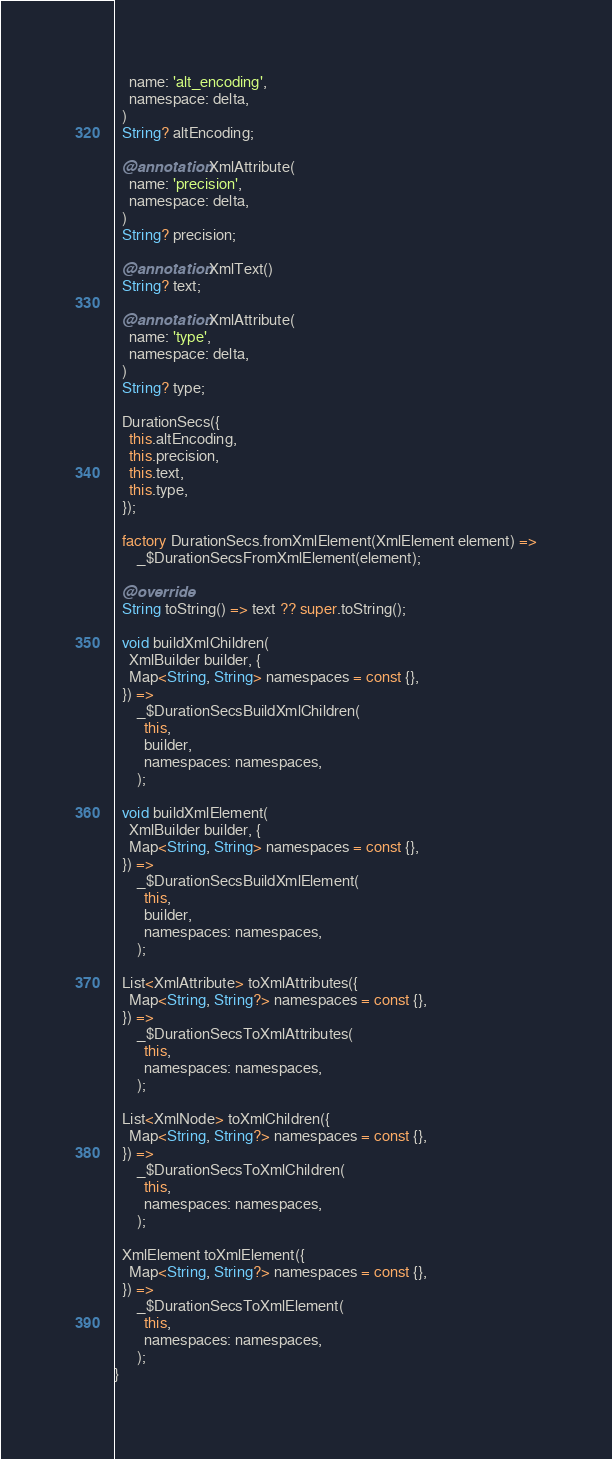Convert code to text. <code><loc_0><loc_0><loc_500><loc_500><_Dart_>    name: 'alt_encoding',
    namespace: delta,
  )
  String? altEncoding;

  @annotation.XmlAttribute(
    name: 'precision',
    namespace: delta,
  )
  String? precision;

  @annotation.XmlText()
  String? text;

  @annotation.XmlAttribute(
    name: 'type',
    namespace: delta,
  )
  String? type;

  DurationSecs({
    this.altEncoding,
    this.precision,
    this.text,
    this.type,
  });

  factory DurationSecs.fromXmlElement(XmlElement element) =>
      _$DurationSecsFromXmlElement(element);

  @override
  String toString() => text ?? super.toString();

  void buildXmlChildren(
    XmlBuilder builder, {
    Map<String, String> namespaces = const {},
  }) =>
      _$DurationSecsBuildXmlChildren(
        this,
        builder,
        namespaces: namespaces,
      );

  void buildXmlElement(
    XmlBuilder builder, {
    Map<String, String> namespaces = const {},
  }) =>
      _$DurationSecsBuildXmlElement(
        this,
        builder,
        namespaces: namespaces,
      );

  List<XmlAttribute> toXmlAttributes({
    Map<String, String?> namespaces = const {},
  }) =>
      _$DurationSecsToXmlAttributes(
        this,
        namespaces: namespaces,
      );

  List<XmlNode> toXmlChildren({
    Map<String, String?> namespaces = const {},
  }) =>
      _$DurationSecsToXmlChildren(
        this,
        namespaces: namespaces,
      );

  XmlElement toXmlElement({
    Map<String, String?> namespaces = const {},
  }) =>
      _$DurationSecsToXmlElement(
        this,
        namespaces: namespaces,
      );
}
</code> 